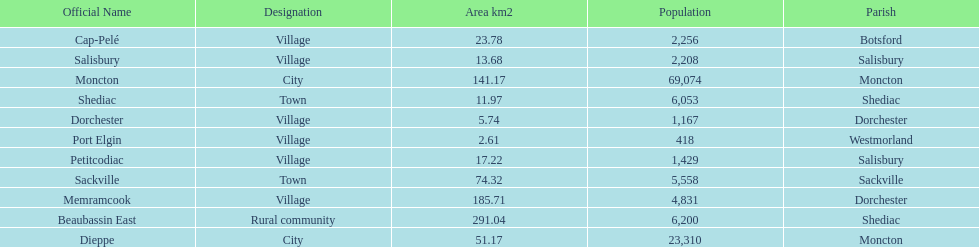How many municipalities have areas that are below 50 square kilometers? 6. 